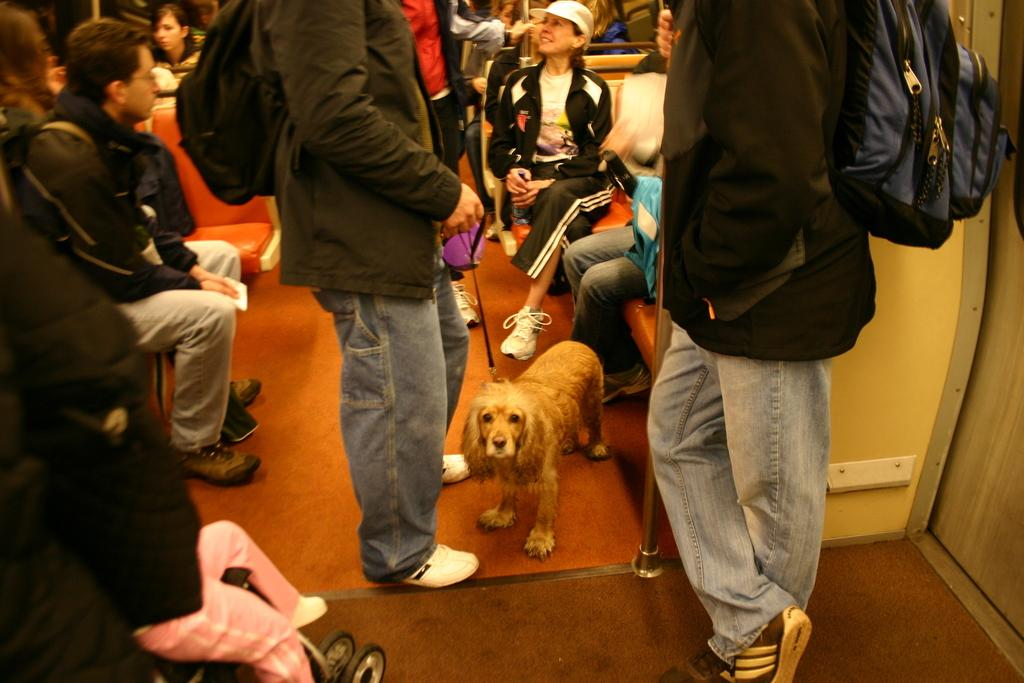How many people are in the foreground of the image? There are two persons standing in the foreground of the image. What is located between the two persons? There is a dog between the two persons. What can be observed in the background of the image? In the background of the image, there are many people sitting. What type of memory is being used by the persons in the image? There is no indication in the image that the persons are using any specific type of memory. How many sticks can be seen in the image? There are no sticks visible in the image. 